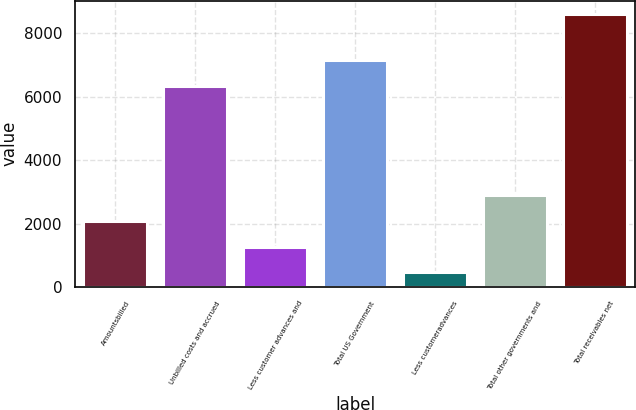<chart> <loc_0><loc_0><loc_500><loc_500><bar_chart><fcel>Amountsbilled<fcel>Unbilled costs and accrued<fcel>Less customer advances and<fcel>Total US Government<fcel>Less customeradvances<fcel>Total other governments and<fcel>Total receivables net<nl><fcel>2091<fcel>6337<fcel>1277<fcel>7151<fcel>463<fcel>2905<fcel>8603<nl></chart> 